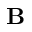Convert formula to latex. <formula><loc_0><loc_0><loc_500><loc_500>{ \mathbf B }</formula> 